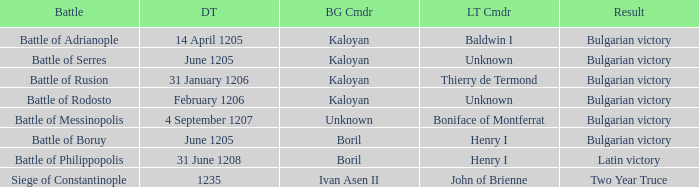Can you parse all the data within this table? {'header': ['Battle', 'DT', 'BG Cmdr', 'LT Cmdr', 'Result'], 'rows': [['Battle of Adrianople', '14 April 1205', 'Kaloyan', 'Baldwin I', 'Bulgarian victory'], ['Battle of Serres', 'June 1205', 'Kaloyan', 'Unknown', 'Bulgarian victory'], ['Battle of Rusion', '31 January 1206', 'Kaloyan', 'Thierry de Termond', 'Bulgarian victory'], ['Battle of Rodosto', 'February 1206', 'Kaloyan', 'Unknown', 'Bulgarian victory'], ['Battle of Messinopolis', '4 September 1207', 'Unknown', 'Boniface of Montferrat', 'Bulgarian victory'], ['Battle of Boruy', 'June 1205', 'Boril', 'Henry I', 'Bulgarian victory'], ['Battle of Philippopolis', '31 June 1208', 'Boril', 'Henry I', 'Latin victory'], ['Siege of Constantinople', '1235', 'Ivan Asen II', 'John of Brienne', 'Two Year Truce']]} Who is the Latin Commander of the Siege of Constantinople? John of Brienne. 